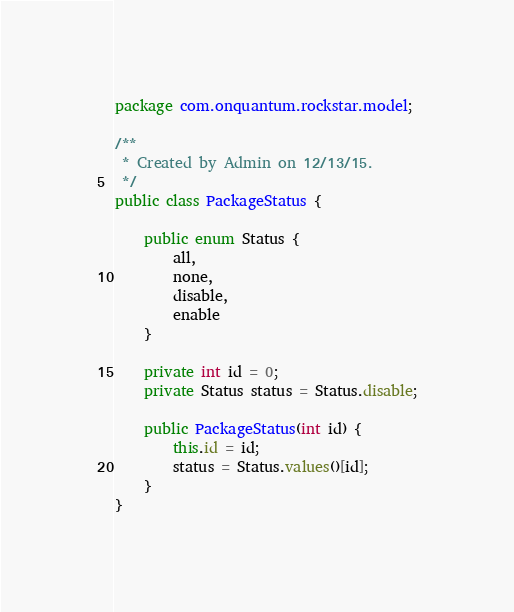Convert code to text. <code><loc_0><loc_0><loc_500><loc_500><_Java_>package com.onquantum.rockstar.model;

/**
 * Created by Admin on 12/13/15.
 */
public class PackageStatus {

    public enum Status {
        all,
        none,
        disable,
        enable
    }

    private int id = 0;
    private Status status = Status.disable;

    public PackageStatus(int id) {
        this.id = id;
        status = Status.values()[id];
    }
}
</code> 